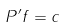<formula> <loc_0><loc_0><loc_500><loc_500>P ^ { \prime } f = c</formula> 